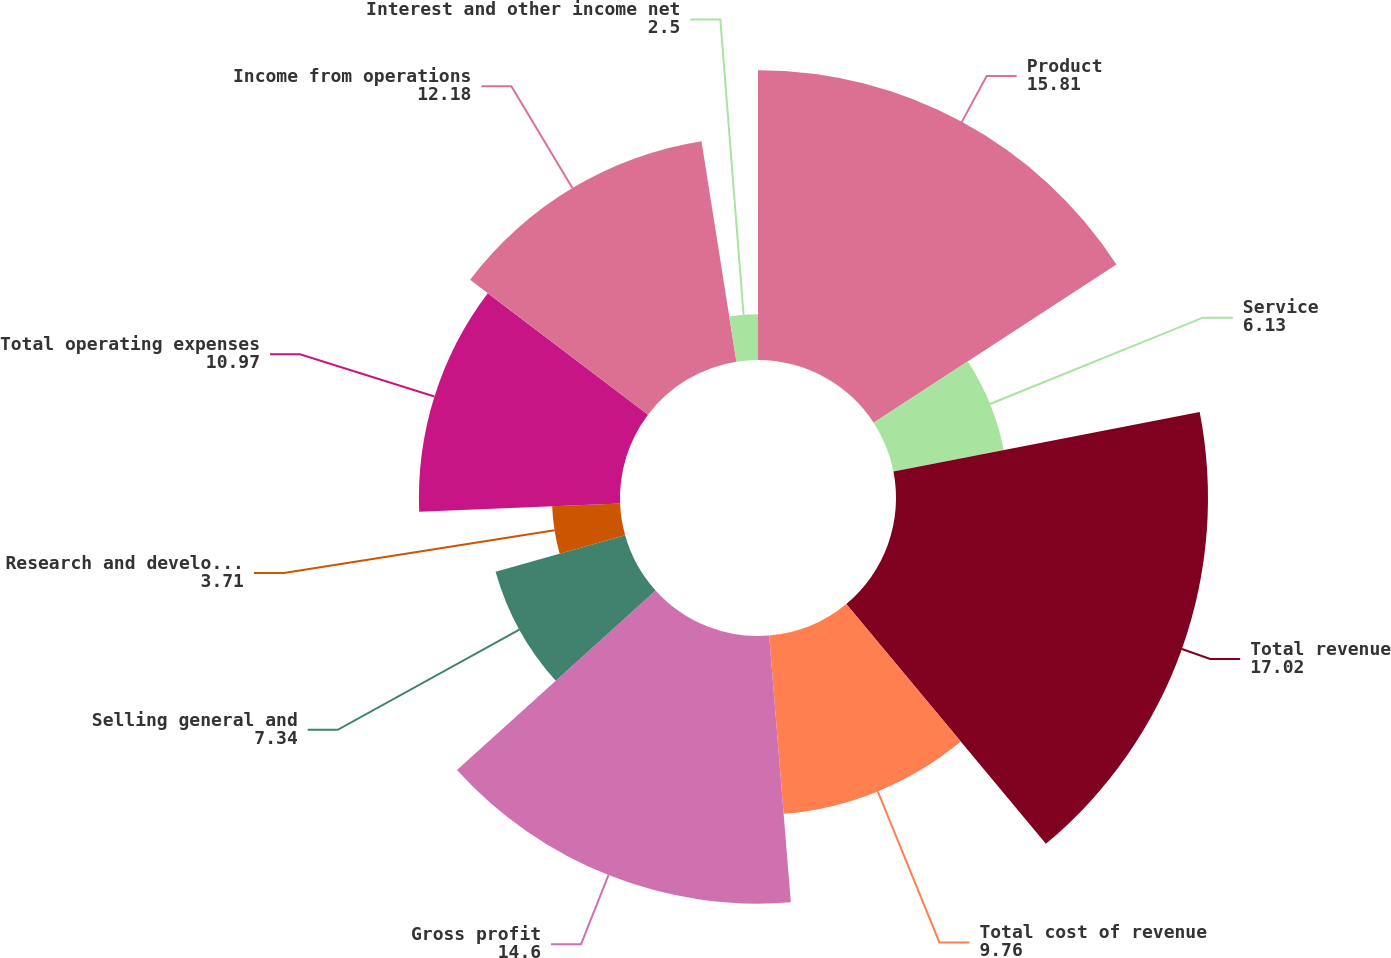<chart> <loc_0><loc_0><loc_500><loc_500><pie_chart><fcel>Product<fcel>Service<fcel>Total revenue<fcel>Total cost of revenue<fcel>Gross profit<fcel>Selling general and<fcel>Research and development<fcel>Total operating expenses<fcel>Income from operations<fcel>Interest and other income net<nl><fcel>15.81%<fcel>6.13%<fcel>17.02%<fcel>9.76%<fcel>14.6%<fcel>7.34%<fcel>3.71%<fcel>10.97%<fcel>12.18%<fcel>2.5%<nl></chart> 